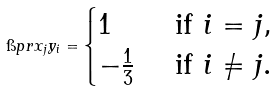Convert formula to latex. <formula><loc_0><loc_0><loc_500><loc_500>\i p r { x _ { j } } { y _ { i } } = \begin{cases} 1 & \text { if } i = j , \\ - \frac { 1 } { 3 } & \text { if } i \neq j . \end{cases}</formula> 